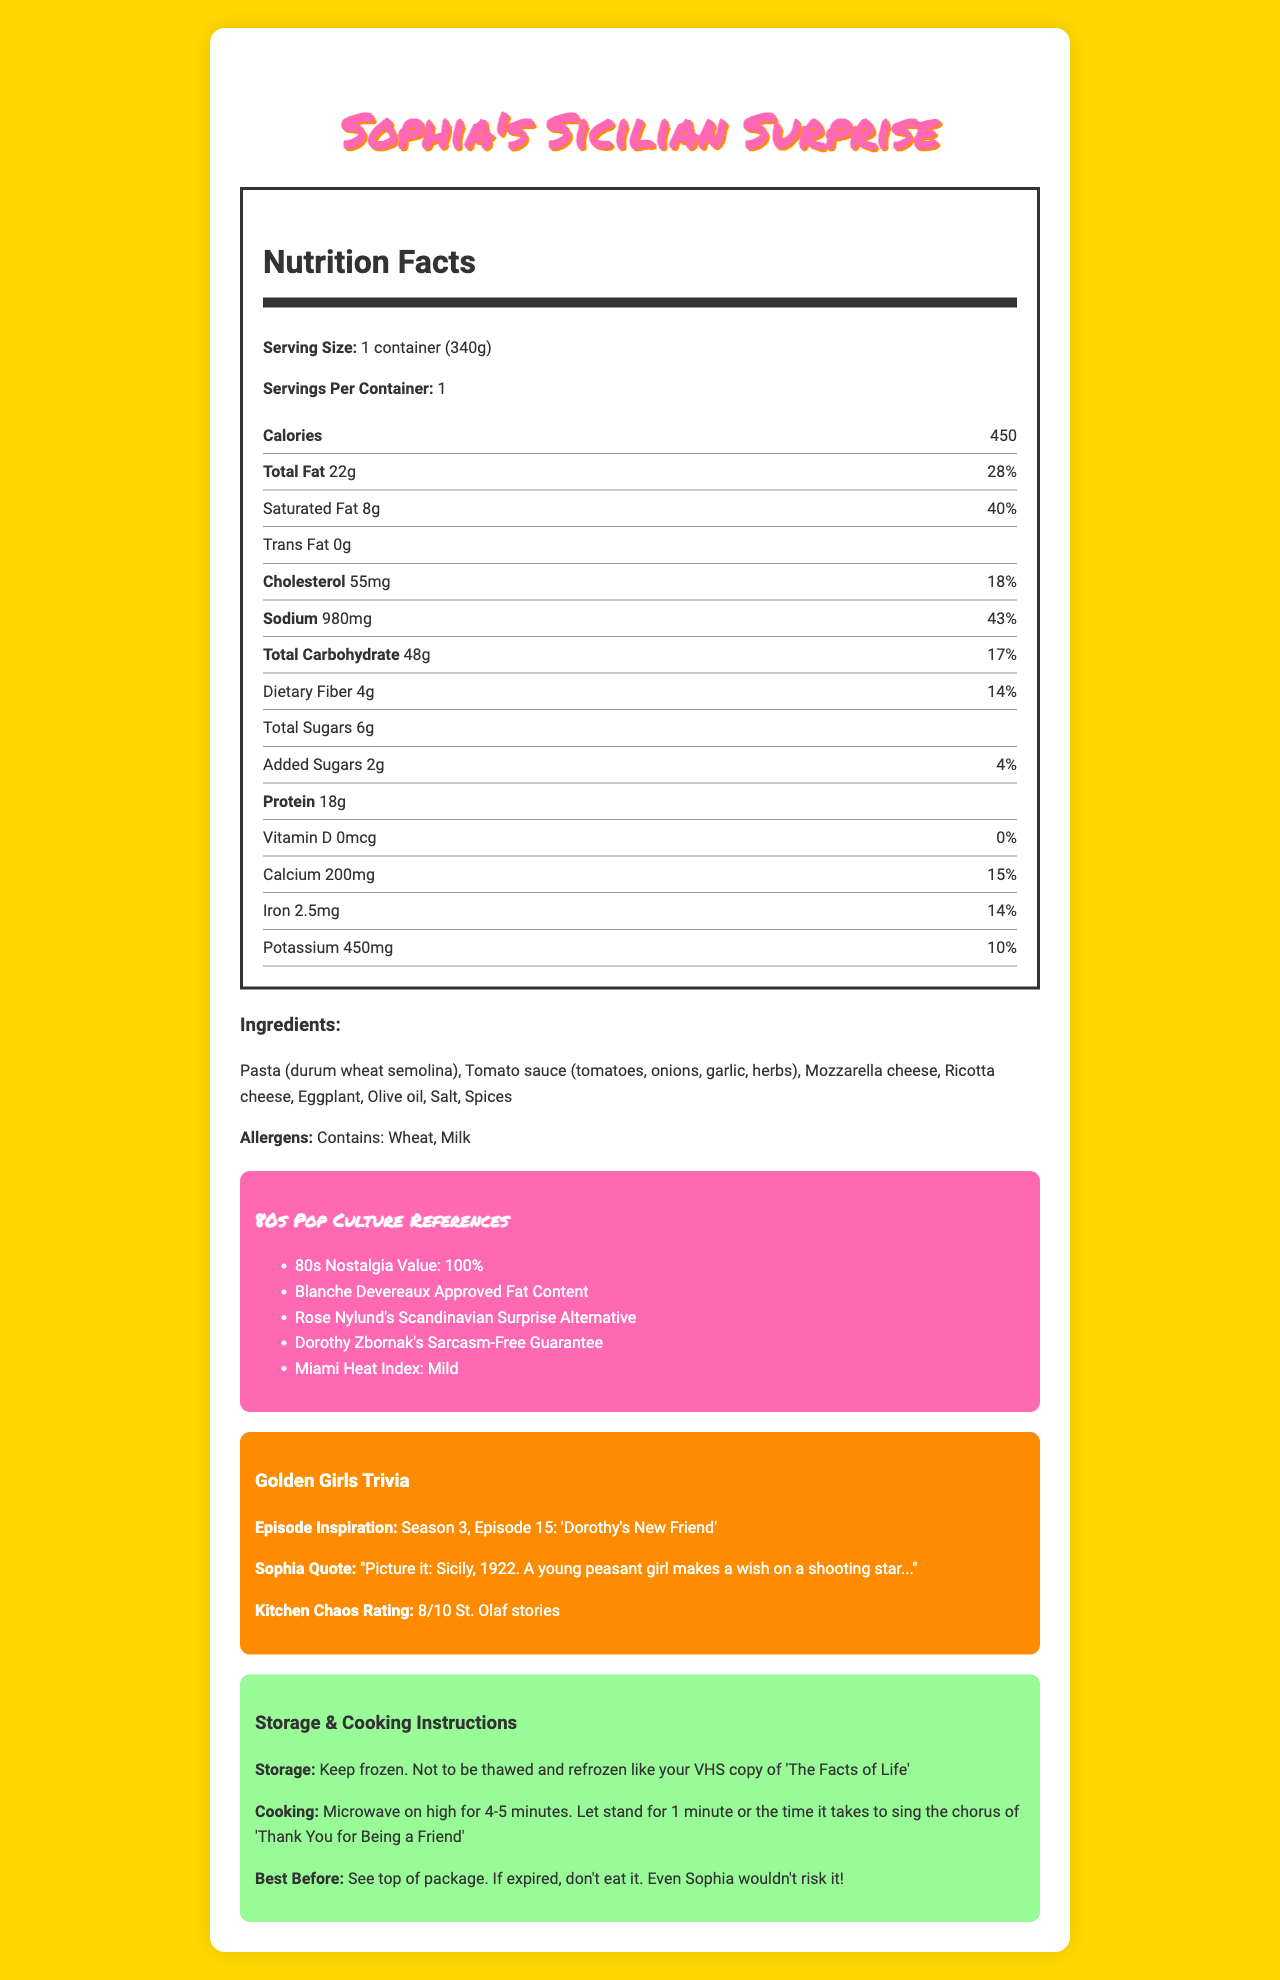what is the serving size of "Sophia's Sicilian Surprise"? The serving size is mentioned at the beginning of the Nutrition Facts section.
Answer: 1 container (340g) how many calories are in one serving of "Sophia's Sicilian Surprise"? The number of calories is listed as "450" in the Nutrition Facts section.
Answer: 450 what is the total fat content in grams and the daily value percentage? The total fat content is listed as 22g and the daily value is 28%.
Answer: 22g, 28% how much saturated fat does "Sophia's Sicilian Surprise" contain? The nutrition label shows saturated fat as 8g, accounting for 40% of the daily value.
Answer: 8g, 40% what is the sodium content in one serving? The Nutrition Facts section lists sodium content as 980mg and 43% of the daily value.
Answer: 980mg, 43% what are the main ingredients in "Sophia's Sicilian Surprise"? The ingredients are listed under the Ingredients section.
Answer: Pasta (durum wheat semolina), Tomato sauce (tomatoes, onions, garlic, herbs), Mozzarella cheese, Ricotta cheese, Eggplant, Olive oil, Salt, Spices how much protein is in "Sophia's Sicilian Surprise"? The nutrition label lists the protein content as 18g.
Answer: 18g what allergens are present in "Sophia's Sicilian Surprise"? The allergens section mentions "Contains: Wheat, Milk".
Answer: Wheat, Milk what percentage of the daily value for calcium does "Sophia's Sicilian Surprise" provide? The daily value percentage for calcium is listed as 15%.
Answer: 15% what episode of Golden Girls inspired "Sophia's Sicilian Surprise"? A. "The Engagement" B. "Dorothy's New Friend" C. "The Way We Met" D. "Yokel Hero" The episode inspiration is mentioned as "Season 3, Episode 15: 'Dorothy's New Friend'".
Answer: B. "Dorothy's New Friend" what is the daily value percentage for total carbohydrates in "Sophia's Sicilian Surprise"? A. 14% B. 28% C. 17% D. 43% The nutrition label lists total carbohydrates as 17%.
Answer: C. 17% does "Sophia's Sicilian Surprise" contain any trans fat? The nutrition label indicates 0g of trans fat.
Answer: No describe the main sections of the document. The document is divided into sections such as Nutrition Facts, Ingredients, Pop Culture References, Golden Girls Trivia, Storage & Cooking Instructions, and Best Before Date.
Answer: The document provides detailed information about "Sophia's Sicilian Surprise" microwave dinner including nutrition facts, ingredients, allergens, 80s pop culture references, Golden Girls trivia, storage and cooking instructions, and best before date. can the storage instructions for "Sophia's Sicilian Surprise" be determined from the document? The storage instructions are provided: "Keep frozen. Not to be thawed and refrozen like your VHS copy of 'The Facts of Life'".
Answer: Yes how much vitamin d is in "Sophia's Sicilian Surprise"? The nutrition label lists vitamin D as 0mcg, with 0% of the daily value.
Answer: 0mcg, 0% what should you do if the best before date has expired? The instruction is mentioned in the Best Before section: "If expired, don't eat it. Even Sophia wouldn't risk it!".
Answer: Don't eat it is "Sophia's Sicilian Surprise" a good source of dietary fiber? The nutrition label lists dietary fiber as 4g, which is 14% of the daily value, making it a good source.
Answer: Yes who approves the fat content in "Sophia's Sicilian Surprise"? The Pop Culture References section mentions "Blanche Devereaux Approved Fat Content".
Answer: Blanche Devereaux how long should you microwave "Sophia's Sicilian Surprise"? The cooking instructions specify to microwave on high for 4-5 minutes.
Answer: 4-5 minutes what is the Miami Heat Index level for "Sophia's Sicilian Surprise"? The Pop Culture References section indicates a Miami Heat Index of Mild.
Answer: Mild where should you look for the best before date on the packaging? The document advises to check the top of the package for the best before date.
Answer: See top of package does "Sophia's Sicilian Surprise" contain any added sugars? The nutrition label indicates there are 2g of added sugars, which is 4% of the daily value.
Answer: 2g, 4% how much iron does "Sophia's Sicilian Surprise" contain as a percentage of the daily value? The daily value percentage for iron is listed as 14%.
Answer: 14% can you determine the cost of "Sophia's Sicilian Surprise" from the document? The document does not provide any information regarding the cost of the product.
Answer: Not enough information 